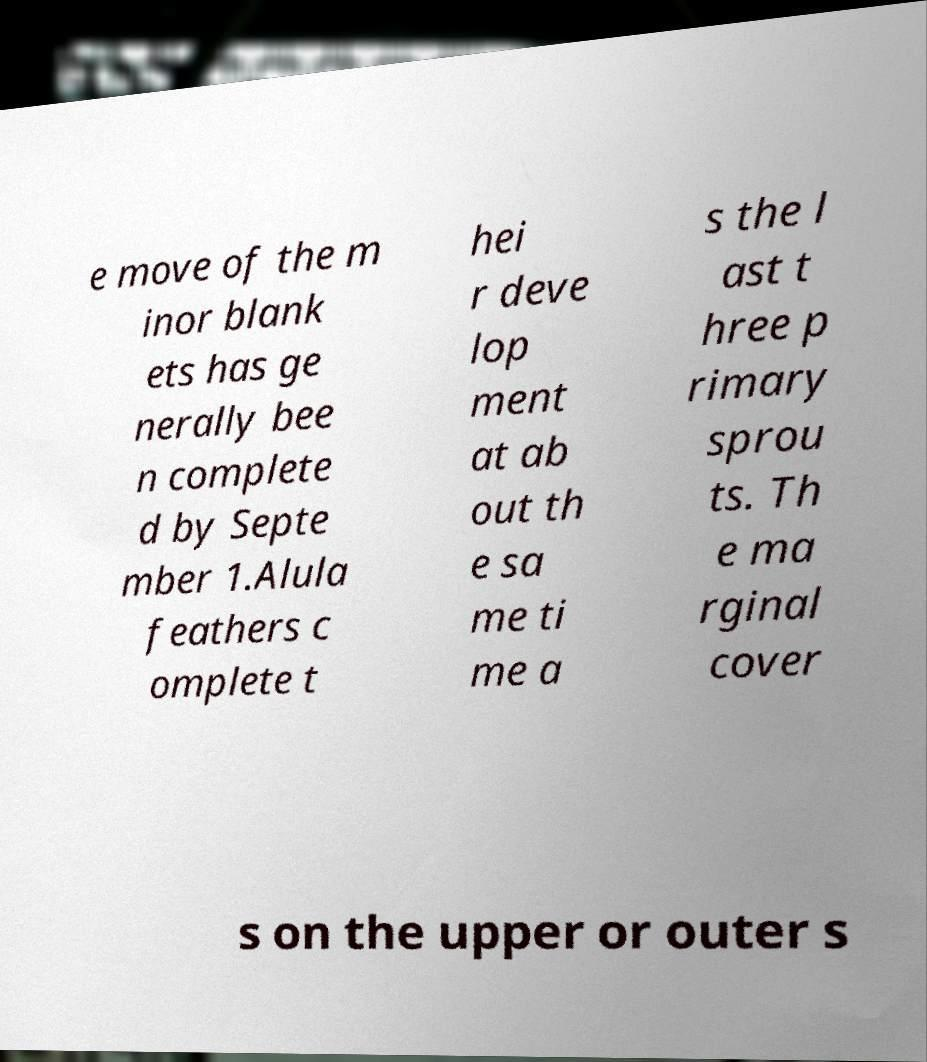Please read and relay the text visible in this image. What does it say? e move of the m inor blank ets has ge nerally bee n complete d by Septe mber 1.Alula feathers c omplete t hei r deve lop ment at ab out th e sa me ti me a s the l ast t hree p rimary sprou ts. Th e ma rginal cover s on the upper or outer s 